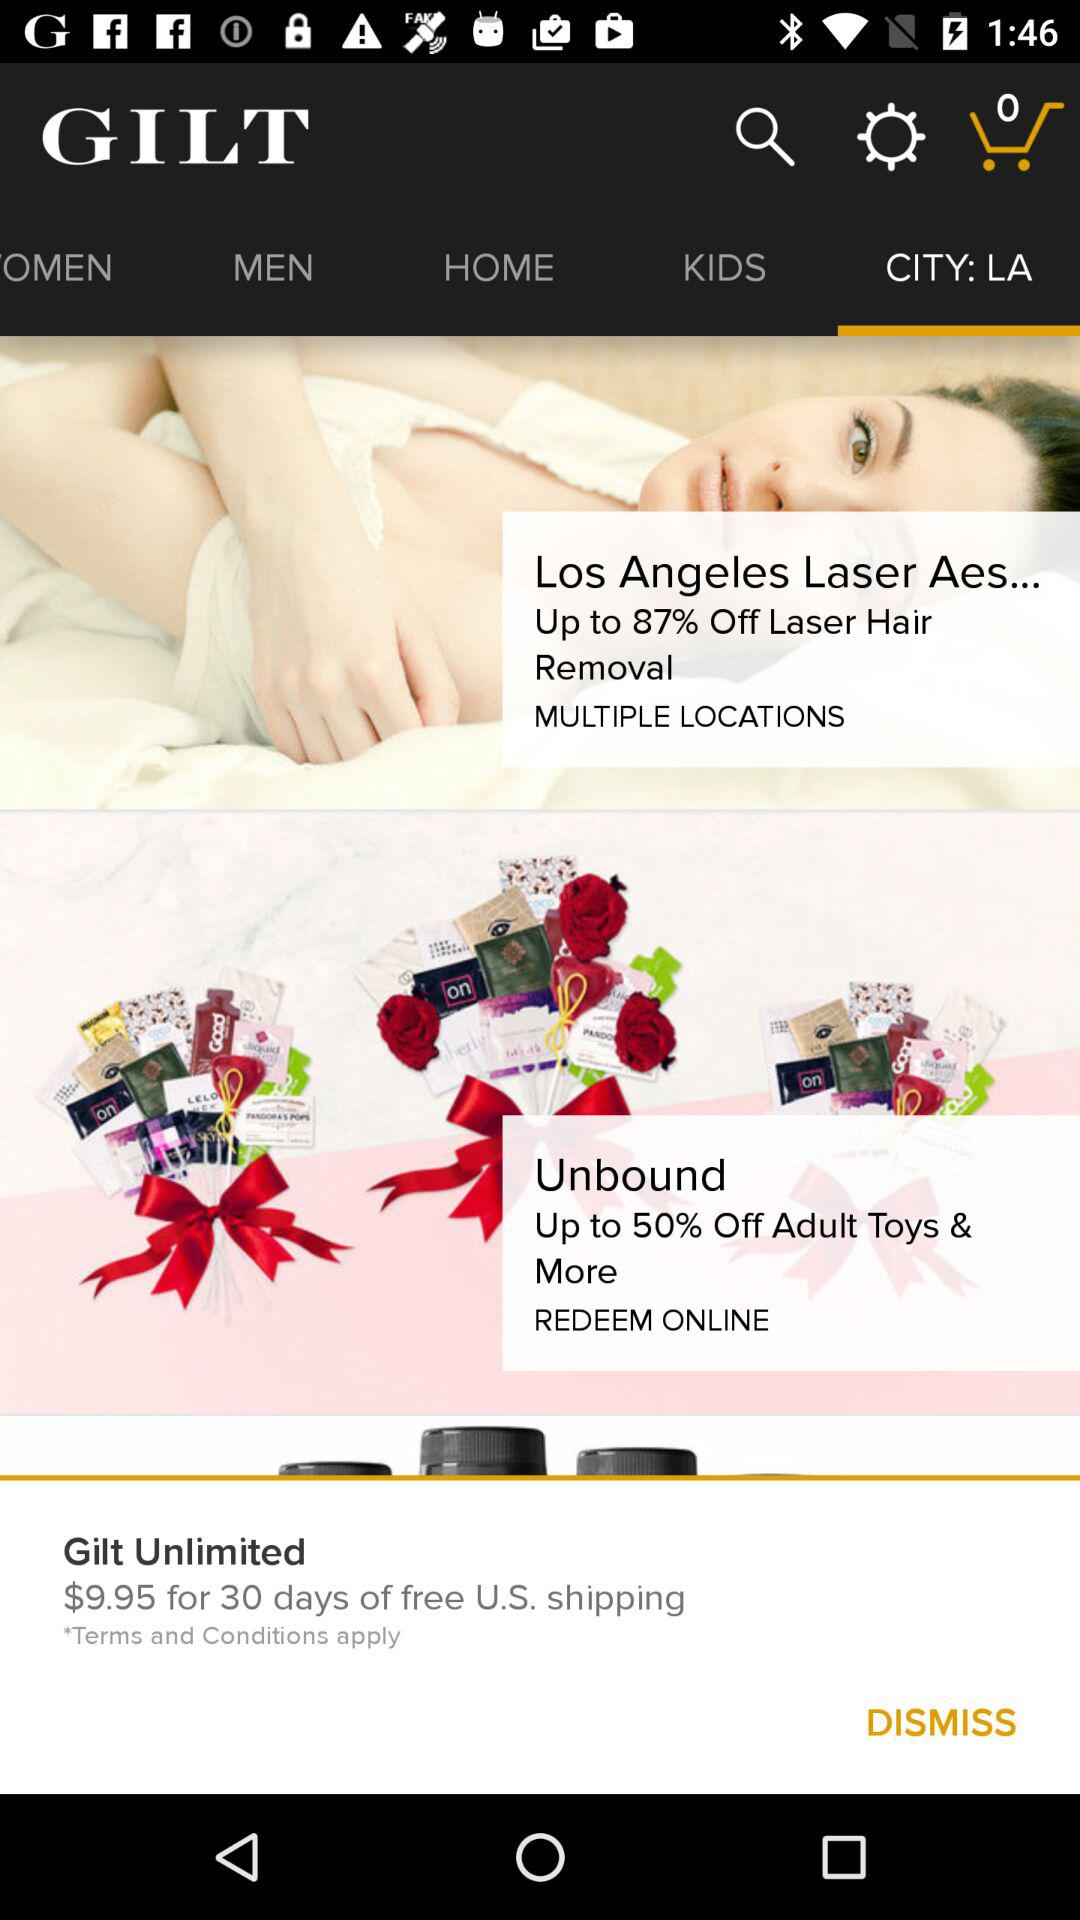What is the price for 30 days of free U.S. shipping? The price for 30 days of free U.S. shipping is $9.95. 